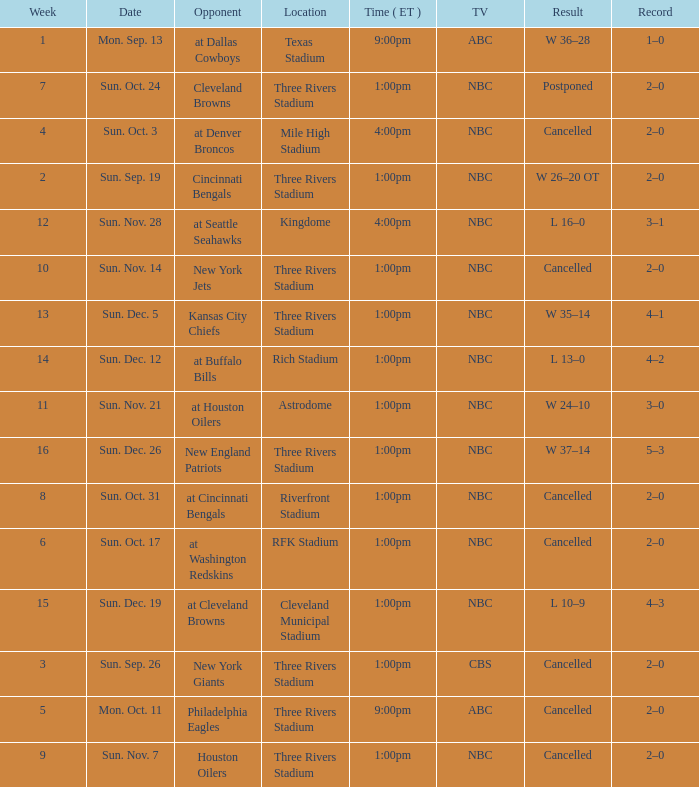What time in eastern standard time was game held at denver broncos? 4:00pm. 